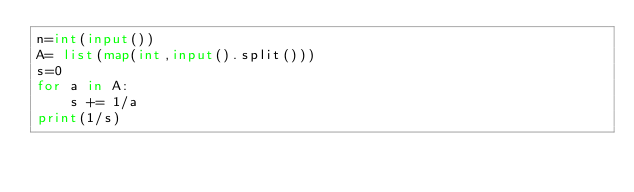Convert code to text. <code><loc_0><loc_0><loc_500><loc_500><_Python_>n=int(input())
A= list(map(int,input().split()))
s=0
for a in A:
    s += 1/a
print(1/s)</code> 